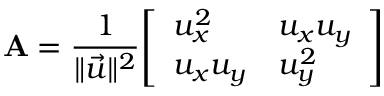Convert formula to latex. <formula><loc_0><loc_0><loc_500><loc_500>A = { \frac { 1 } { \| { \vec { u } } \| ^ { 2 } } } { \left [ \begin{array} { l l } { u _ { x } ^ { 2 } } & { u _ { x } u _ { y } } \\ { u _ { x } u _ { y } } & { u _ { y } ^ { 2 } } \end{array} \right ] }</formula> 